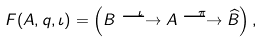<formula> <loc_0><loc_0><loc_500><loc_500>F ( A , q , \iota ) = \left ( B \overset { \iota } { \longrightarrow } A \overset { \pi } { \longrightarrow } \widehat { B } \right ) ,</formula> 